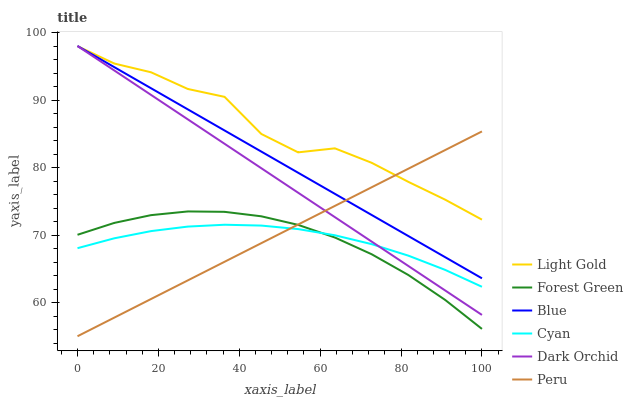Does Forest Green have the minimum area under the curve?
Answer yes or no. Yes. Does Light Gold have the maximum area under the curve?
Answer yes or no. Yes. Does Dark Orchid have the minimum area under the curve?
Answer yes or no. No. Does Dark Orchid have the maximum area under the curve?
Answer yes or no. No. Is Blue the smoothest?
Answer yes or no. Yes. Is Light Gold the roughest?
Answer yes or no. Yes. Is Dark Orchid the smoothest?
Answer yes or no. No. Is Dark Orchid the roughest?
Answer yes or no. No. Does Peru have the lowest value?
Answer yes or no. Yes. Does Dark Orchid have the lowest value?
Answer yes or no. No. Does Dark Orchid have the highest value?
Answer yes or no. Yes. Does Forest Green have the highest value?
Answer yes or no. No. Is Forest Green less than Blue?
Answer yes or no. Yes. Is Dark Orchid greater than Forest Green?
Answer yes or no. Yes. Does Blue intersect Light Gold?
Answer yes or no. Yes. Is Blue less than Light Gold?
Answer yes or no. No. Is Blue greater than Light Gold?
Answer yes or no. No. Does Forest Green intersect Blue?
Answer yes or no. No. 